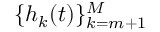<formula> <loc_0><loc_0><loc_500><loc_500>\{ h _ { k } ( t ) \} _ { k = m + 1 } ^ { M }</formula> 